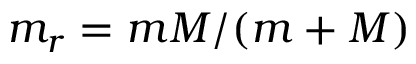<formula> <loc_0><loc_0><loc_500><loc_500>m _ { r } = m M / ( m + M )</formula> 